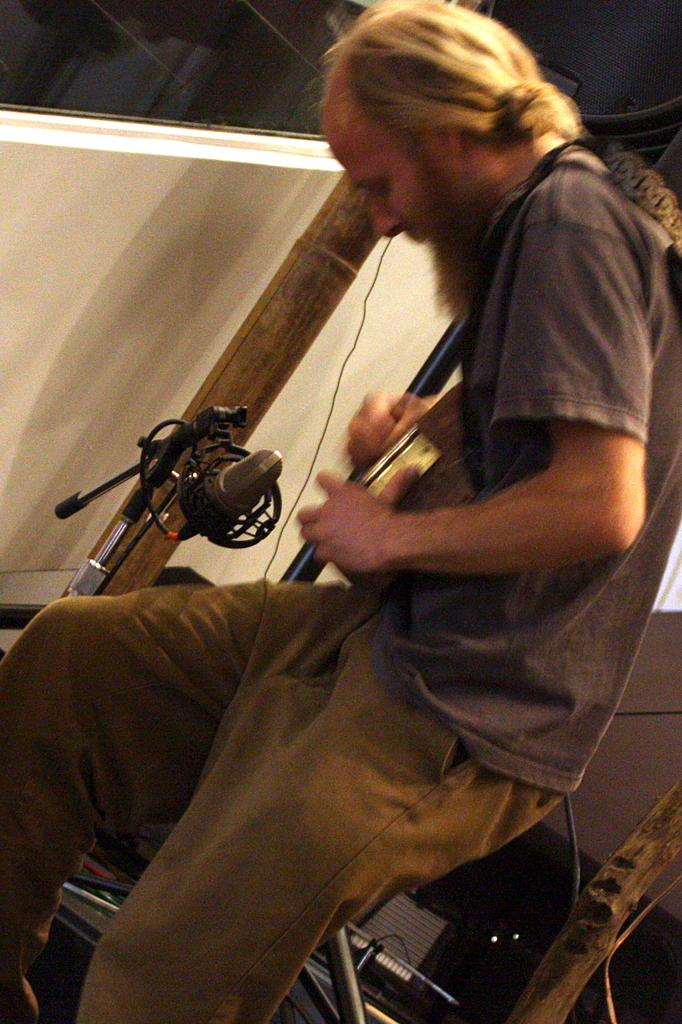What is the main subject of the image? There is a person standing in the image. What is the person holding in their hands? The person is holding an object in their hands. Can you describe any other objects visible in the image? There are other objects visible in the background of the image. Can you tell me how many cats are sitting on the yoke in the image? There is no yoke or cat present in the image. 